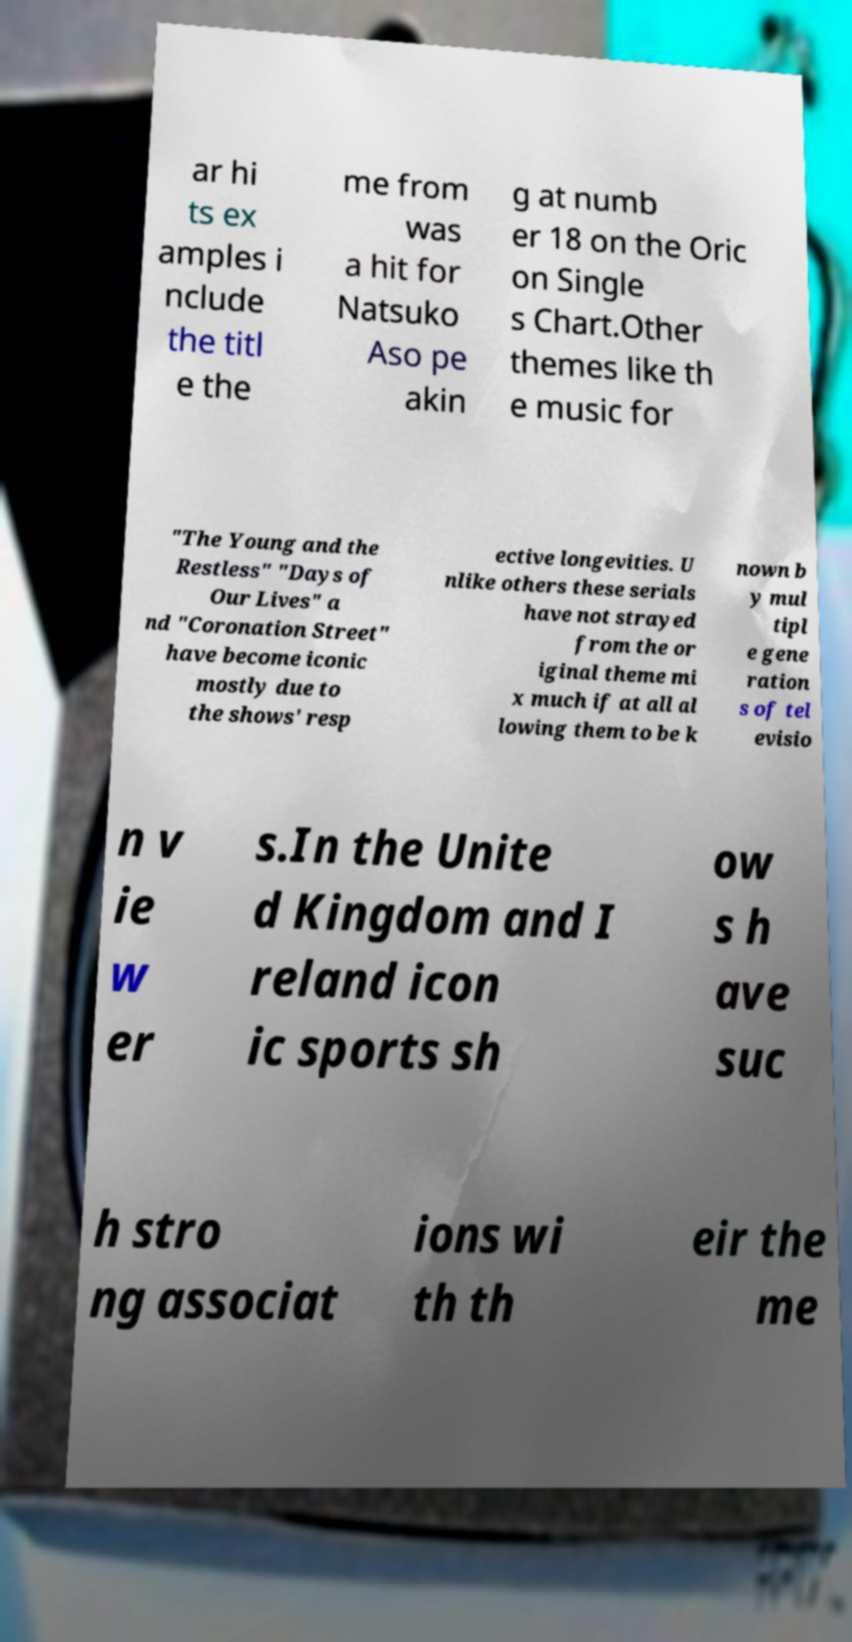Can you accurately transcribe the text from the provided image for me? ar hi ts ex amples i nclude the titl e the me from was a hit for Natsuko Aso pe akin g at numb er 18 on the Oric on Single s Chart.Other themes like th e music for "The Young and the Restless" "Days of Our Lives" a nd "Coronation Street" have become iconic mostly due to the shows' resp ective longevities. U nlike others these serials have not strayed from the or iginal theme mi x much if at all al lowing them to be k nown b y mul tipl e gene ration s of tel evisio n v ie w er s.In the Unite d Kingdom and I reland icon ic sports sh ow s h ave suc h stro ng associat ions wi th th eir the me 